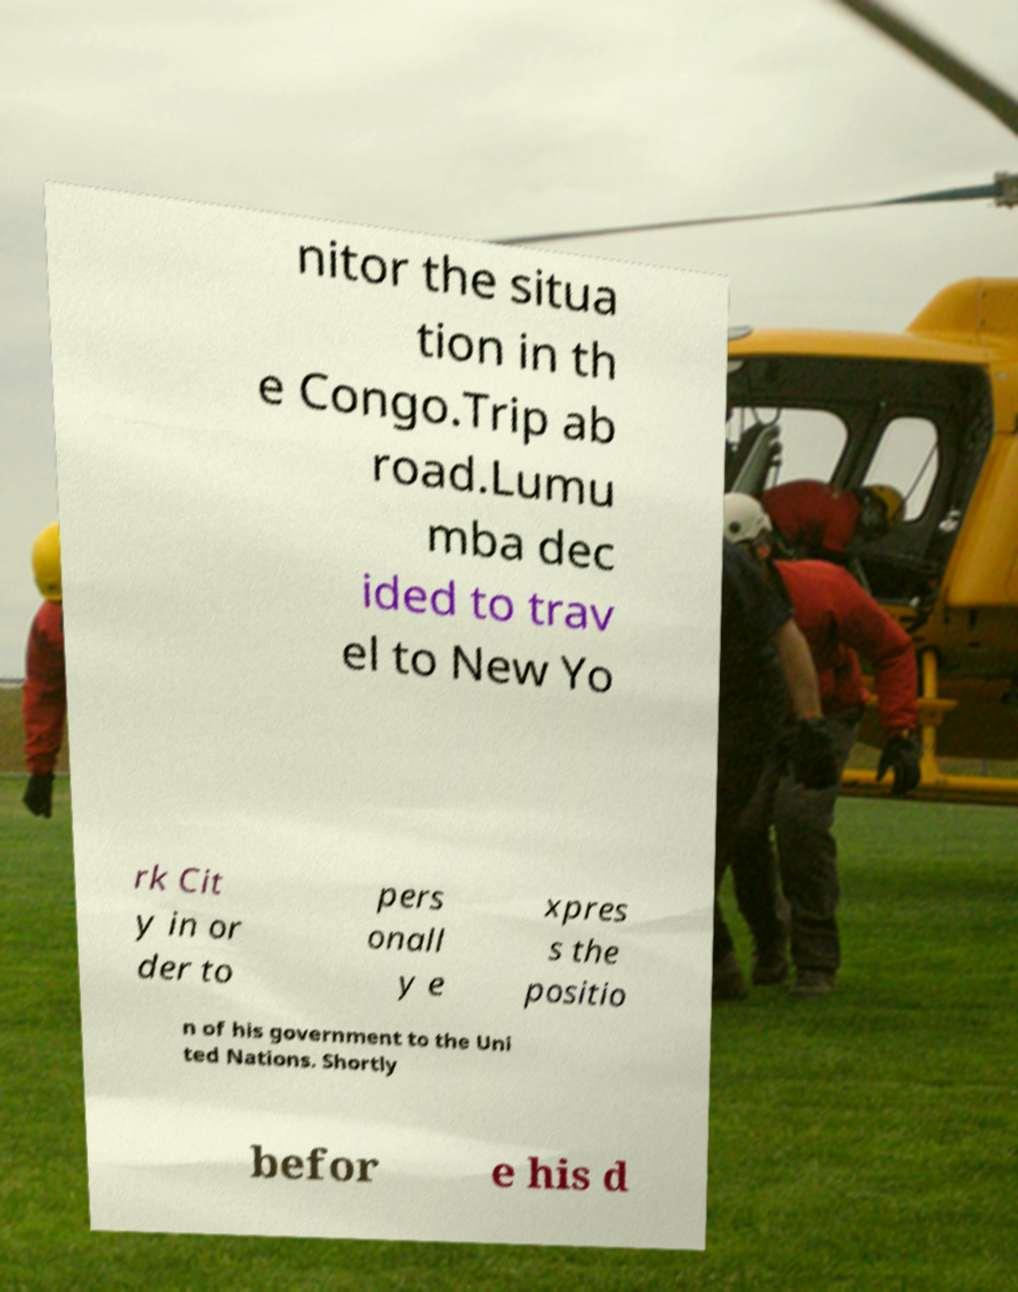What messages or text are displayed in this image? I need them in a readable, typed format. nitor the situa tion in th e Congo.Trip ab road.Lumu mba dec ided to trav el to New Yo rk Cit y in or der to pers onall y e xpres s the positio n of his government to the Uni ted Nations. Shortly befor e his d 